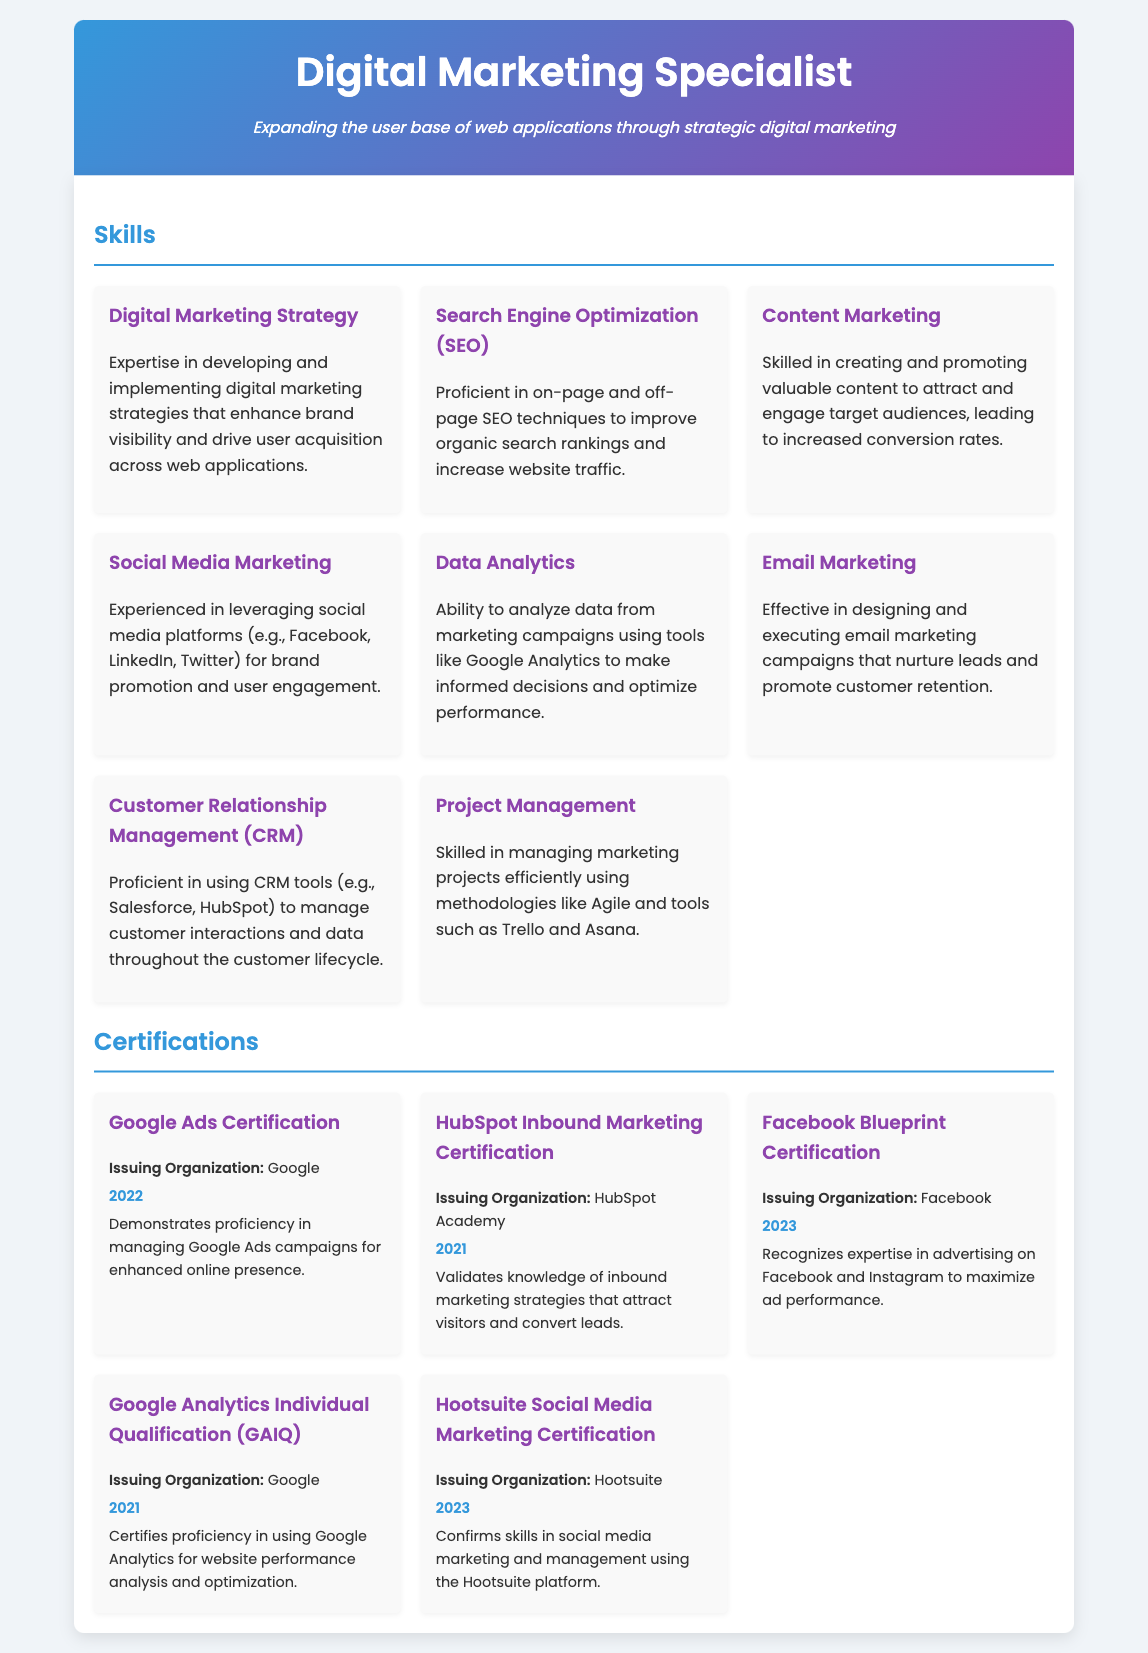what is the title of the document? The title of the document is given as the main heading in the header section.
Answer: Digital Marketing Specialist how many skills are mentioned in the document? The document lists the skills in a section that includes a grid layout. Counting the skills present gives the total.
Answer: 8 who issued the Google Ads Certification? The issuing organization for the Google Ads Certification is specified in the certification section.
Answer: Google in what year was the Facebook Blueprint Certification obtained? The year is mentioned alongside each certification in the document, specifically for Facebook Blueprint.
Answer: 2023 what is the focus of the Content Marketing skill? The focus is detailed in the description of the Content Marketing skill section within the skills.
Answer: Attract and engage target audiences which certification validates knowledge of inbound marketing strategies? The specific certification is noted in the certifying body section dedicated to inbound marketing.
Answer: HubSpot Inbound Marketing Certification how many years apart were the Google Analytics Individual Qualification and the HubSpot Inbound Marketing certifications earned? By comparing the years mentioned for both certifications in the document, I can determine the difference.
Answer: 2 years which skill emphasizes the use of CRM tools? The skill section describes various skills, and one specifically discusses CRM tools in depth.
Answer: Customer Relationship Management (CRM) what digital marketing strategy is focused on driving user acquisition? This is described in the introduction and specifically in the Digital Marketing Strategy skill section.
Answer: Digital Marketing Strategy 